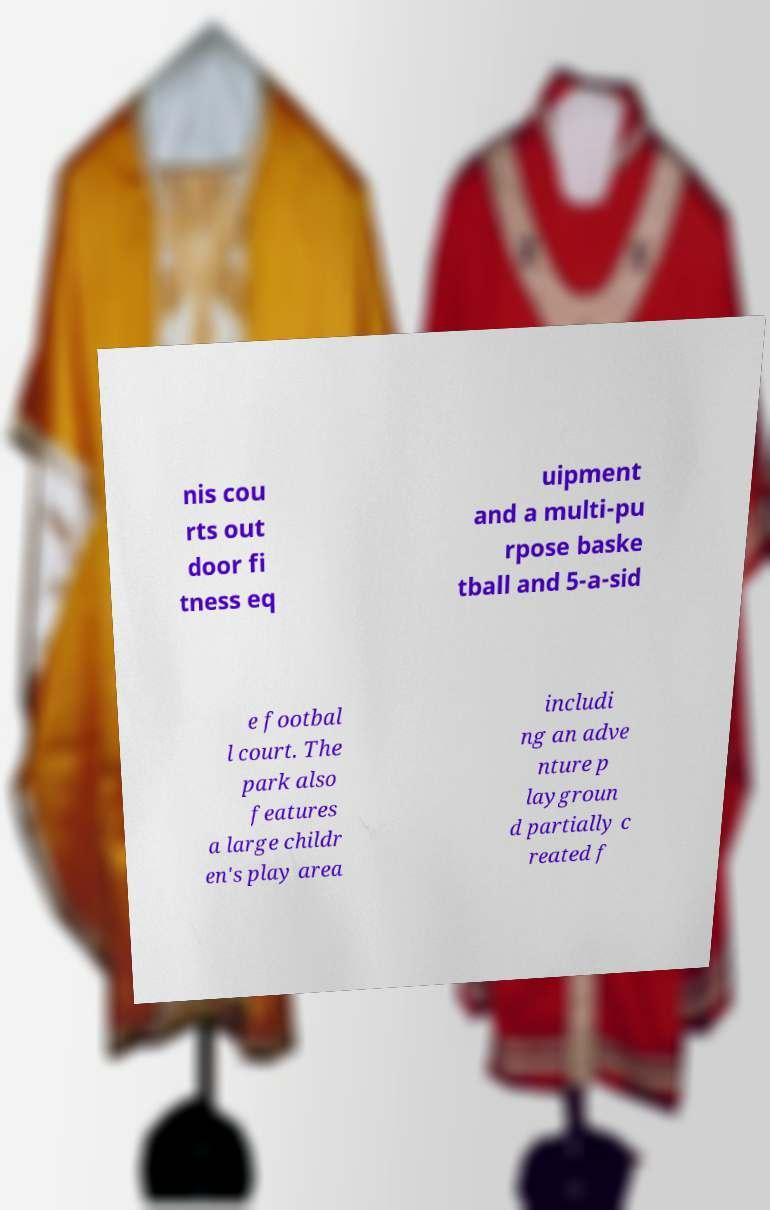What messages or text are displayed in this image? I need them in a readable, typed format. nis cou rts out door fi tness eq uipment and a multi-pu rpose baske tball and 5-a-sid e footbal l court. The park also features a large childr en's play area includi ng an adve nture p laygroun d partially c reated f 